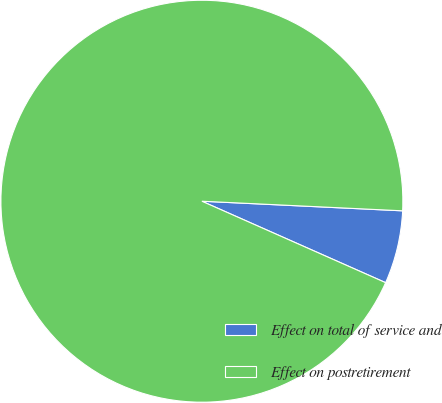Convert chart to OTSL. <chart><loc_0><loc_0><loc_500><loc_500><pie_chart><fcel>Effect on total of service and<fcel>Effect on postretirement<nl><fcel>5.88%<fcel>94.12%<nl></chart> 